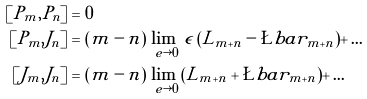<formula> <loc_0><loc_0><loc_500><loc_500>[ P _ { m } , P _ { n } ] & = 0 \\ [ P _ { m } , J _ { n } ] & = ( m - n ) \, \lim _ { \ e \rightarrow 0 } \, \epsilon \, ( L _ { m + n } - \L b a r _ { m + n } ) + \dots \\ [ J _ { m } , J _ { n } ] & = ( m - n ) \, \lim _ { \ e \rightarrow 0 } \, ( L _ { m + n } + \L b a r _ { m + n } ) + \dots</formula> 